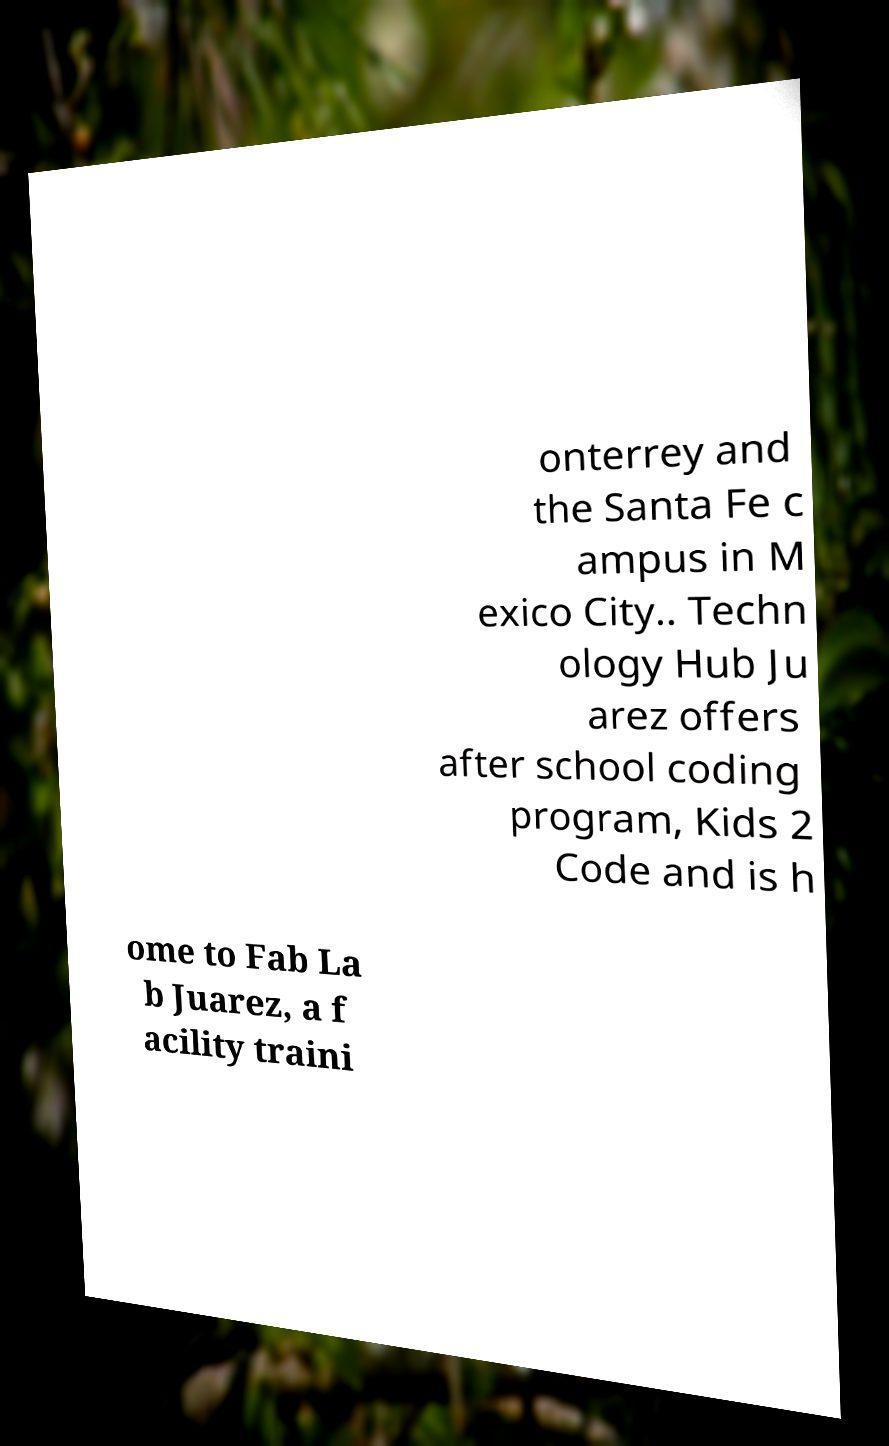There's text embedded in this image that I need extracted. Can you transcribe it verbatim? onterrey and the Santa Fe c ampus in M exico City.. Techn ology Hub Ju arez offers after school coding program, Kids 2 Code and is h ome to Fab La b Juarez, a f acility traini 